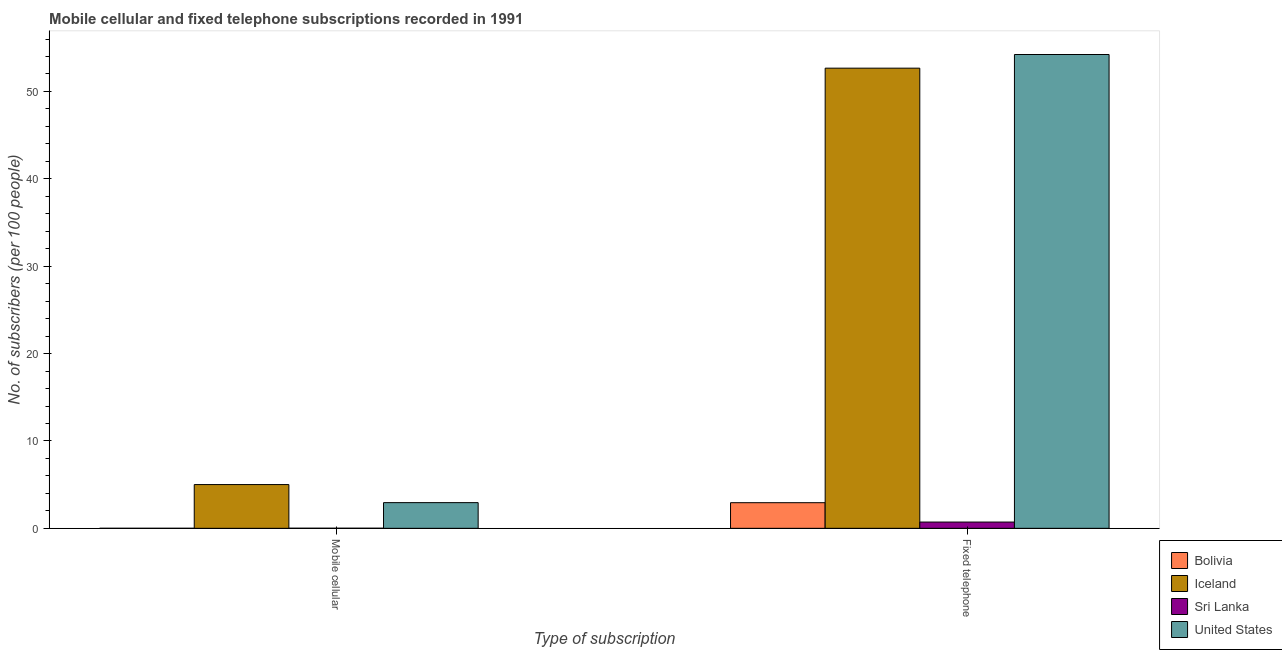How many different coloured bars are there?
Provide a succinct answer. 4. How many groups of bars are there?
Your response must be concise. 2. Are the number of bars per tick equal to the number of legend labels?
Keep it short and to the point. Yes. How many bars are there on the 1st tick from the left?
Ensure brevity in your answer.  4. What is the label of the 1st group of bars from the left?
Give a very brief answer. Mobile cellular. What is the number of fixed telephone subscribers in Sri Lanka?
Your response must be concise. 0.72. Across all countries, what is the maximum number of mobile cellular subscribers?
Offer a terse response. 5.01. Across all countries, what is the minimum number of mobile cellular subscribers?
Provide a succinct answer. 0. In which country was the number of mobile cellular subscribers maximum?
Give a very brief answer. Iceland. In which country was the number of fixed telephone subscribers minimum?
Provide a succinct answer. Sri Lanka. What is the total number of mobile cellular subscribers in the graph?
Make the answer very short. 7.96. What is the difference between the number of fixed telephone subscribers in Bolivia and that in Sri Lanka?
Keep it short and to the point. 2.22. What is the difference between the number of mobile cellular subscribers in Sri Lanka and the number of fixed telephone subscribers in United States?
Keep it short and to the point. -54.22. What is the average number of fixed telephone subscribers per country?
Your response must be concise. 27.64. What is the difference between the number of fixed telephone subscribers and number of mobile cellular subscribers in United States?
Make the answer very short. 51.29. What is the ratio of the number of mobile cellular subscribers in Iceland to that in Sri Lanka?
Provide a short and direct response. 487.77. Is the number of fixed telephone subscribers in Sri Lanka less than that in Bolivia?
Offer a terse response. Yes. What does the 2nd bar from the left in Fixed telephone represents?
Give a very brief answer. Iceland. How many countries are there in the graph?
Offer a very short reply. 4. What is the difference between two consecutive major ticks on the Y-axis?
Keep it short and to the point. 10. Does the graph contain grids?
Offer a terse response. No. How are the legend labels stacked?
Offer a terse response. Vertical. What is the title of the graph?
Provide a short and direct response. Mobile cellular and fixed telephone subscriptions recorded in 1991. Does "Ukraine" appear as one of the legend labels in the graph?
Provide a short and direct response. No. What is the label or title of the X-axis?
Provide a succinct answer. Type of subscription. What is the label or title of the Y-axis?
Your answer should be very brief. No. of subscribers (per 100 people). What is the No. of subscribers (per 100 people) in Bolivia in Mobile cellular?
Provide a succinct answer. 0. What is the No. of subscribers (per 100 people) of Iceland in Mobile cellular?
Keep it short and to the point. 5.01. What is the No. of subscribers (per 100 people) in Sri Lanka in Mobile cellular?
Provide a succinct answer. 0.01. What is the No. of subscribers (per 100 people) in United States in Mobile cellular?
Keep it short and to the point. 2.94. What is the No. of subscribers (per 100 people) in Bolivia in Fixed telephone?
Keep it short and to the point. 2.93. What is the No. of subscribers (per 100 people) of Iceland in Fixed telephone?
Make the answer very short. 52.67. What is the No. of subscribers (per 100 people) of Sri Lanka in Fixed telephone?
Provide a short and direct response. 0.72. What is the No. of subscribers (per 100 people) of United States in Fixed telephone?
Provide a succinct answer. 54.23. Across all Type of subscription, what is the maximum No. of subscribers (per 100 people) in Bolivia?
Make the answer very short. 2.93. Across all Type of subscription, what is the maximum No. of subscribers (per 100 people) of Iceland?
Offer a terse response. 52.67. Across all Type of subscription, what is the maximum No. of subscribers (per 100 people) of Sri Lanka?
Your answer should be very brief. 0.72. Across all Type of subscription, what is the maximum No. of subscribers (per 100 people) in United States?
Offer a terse response. 54.23. Across all Type of subscription, what is the minimum No. of subscribers (per 100 people) of Bolivia?
Provide a succinct answer. 0. Across all Type of subscription, what is the minimum No. of subscribers (per 100 people) of Iceland?
Provide a succinct answer. 5.01. Across all Type of subscription, what is the minimum No. of subscribers (per 100 people) in Sri Lanka?
Your response must be concise. 0.01. Across all Type of subscription, what is the minimum No. of subscribers (per 100 people) of United States?
Make the answer very short. 2.94. What is the total No. of subscribers (per 100 people) in Bolivia in the graph?
Your answer should be compact. 2.94. What is the total No. of subscribers (per 100 people) in Iceland in the graph?
Offer a terse response. 57.67. What is the total No. of subscribers (per 100 people) in Sri Lanka in the graph?
Your response must be concise. 0.73. What is the total No. of subscribers (per 100 people) of United States in the graph?
Keep it short and to the point. 57.17. What is the difference between the No. of subscribers (per 100 people) of Bolivia in Mobile cellular and that in Fixed telephone?
Offer a terse response. -2.93. What is the difference between the No. of subscribers (per 100 people) in Iceland in Mobile cellular and that in Fixed telephone?
Your answer should be very brief. -47.66. What is the difference between the No. of subscribers (per 100 people) of Sri Lanka in Mobile cellular and that in Fixed telephone?
Provide a succinct answer. -0.71. What is the difference between the No. of subscribers (per 100 people) of United States in Mobile cellular and that in Fixed telephone?
Keep it short and to the point. -51.29. What is the difference between the No. of subscribers (per 100 people) in Bolivia in Mobile cellular and the No. of subscribers (per 100 people) in Iceland in Fixed telephone?
Provide a succinct answer. -52.66. What is the difference between the No. of subscribers (per 100 people) in Bolivia in Mobile cellular and the No. of subscribers (per 100 people) in Sri Lanka in Fixed telephone?
Make the answer very short. -0.71. What is the difference between the No. of subscribers (per 100 people) in Bolivia in Mobile cellular and the No. of subscribers (per 100 people) in United States in Fixed telephone?
Your answer should be compact. -54.23. What is the difference between the No. of subscribers (per 100 people) of Iceland in Mobile cellular and the No. of subscribers (per 100 people) of Sri Lanka in Fixed telephone?
Your answer should be very brief. 4.29. What is the difference between the No. of subscribers (per 100 people) of Iceland in Mobile cellular and the No. of subscribers (per 100 people) of United States in Fixed telephone?
Make the answer very short. -49.22. What is the difference between the No. of subscribers (per 100 people) in Sri Lanka in Mobile cellular and the No. of subscribers (per 100 people) in United States in Fixed telephone?
Give a very brief answer. -54.22. What is the average No. of subscribers (per 100 people) in Bolivia per Type of subscription?
Provide a succinct answer. 1.47. What is the average No. of subscribers (per 100 people) in Iceland per Type of subscription?
Offer a very short reply. 28.84. What is the average No. of subscribers (per 100 people) in Sri Lanka per Type of subscription?
Provide a succinct answer. 0.36. What is the average No. of subscribers (per 100 people) of United States per Type of subscription?
Offer a very short reply. 28.58. What is the difference between the No. of subscribers (per 100 people) in Bolivia and No. of subscribers (per 100 people) in Iceland in Mobile cellular?
Provide a short and direct response. -5. What is the difference between the No. of subscribers (per 100 people) in Bolivia and No. of subscribers (per 100 people) in Sri Lanka in Mobile cellular?
Your answer should be very brief. -0.01. What is the difference between the No. of subscribers (per 100 people) in Bolivia and No. of subscribers (per 100 people) in United States in Mobile cellular?
Make the answer very short. -2.94. What is the difference between the No. of subscribers (per 100 people) of Iceland and No. of subscribers (per 100 people) of Sri Lanka in Mobile cellular?
Offer a terse response. 5. What is the difference between the No. of subscribers (per 100 people) of Iceland and No. of subscribers (per 100 people) of United States in Mobile cellular?
Make the answer very short. 2.07. What is the difference between the No. of subscribers (per 100 people) in Sri Lanka and No. of subscribers (per 100 people) in United States in Mobile cellular?
Make the answer very short. -2.93. What is the difference between the No. of subscribers (per 100 people) in Bolivia and No. of subscribers (per 100 people) in Iceland in Fixed telephone?
Ensure brevity in your answer.  -49.73. What is the difference between the No. of subscribers (per 100 people) in Bolivia and No. of subscribers (per 100 people) in Sri Lanka in Fixed telephone?
Make the answer very short. 2.22. What is the difference between the No. of subscribers (per 100 people) of Bolivia and No. of subscribers (per 100 people) of United States in Fixed telephone?
Keep it short and to the point. -51.3. What is the difference between the No. of subscribers (per 100 people) in Iceland and No. of subscribers (per 100 people) in Sri Lanka in Fixed telephone?
Provide a succinct answer. 51.95. What is the difference between the No. of subscribers (per 100 people) in Iceland and No. of subscribers (per 100 people) in United States in Fixed telephone?
Offer a very short reply. -1.56. What is the difference between the No. of subscribers (per 100 people) of Sri Lanka and No. of subscribers (per 100 people) of United States in Fixed telephone?
Ensure brevity in your answer.  -53.51. What is the ratio of the No. of subscribers (per 100 people) in Bolivia in Mobile cellular to that in Fixed telephone?
Keep it short and to the point. 0. What is the ratio of the No. of subscribers (per 100 people) of Iceland in Mobile cellular to that in Fixed telephone?
Ensure brevity in your answer.  0.1. What is the ratio of the No. of subscribers (per 100 people) in Sri Lanka in Mobile cellular to that in Fixed telephone?
Ensure brevity in your answer.  0.01. What is the ratio of the No. of subscribers (per 100 people) in United States in Mobile cellular to that in Fixed telephone?
Provide a short and direct response. 0.05. What is the difference between the highest and the second highest No. of subscribers (per 100 people) in Bolivia?
Ensure brevity in your answer.  2.93. What is the difference between the highest and the second highest No. of subscribers (per 100 people) in Iceland?
Provide a short and direct response. 47.66. What is the difference between the highest and the second highest No. of subscribers (per 100 people) in Sri Lanka?
Offer a very short reply. 0.71. What is the difference between the highest and the second highest No. of subscribers (per 100 people) in United States?
Give a very brief answer. 51.29. What is the difference between the highest and the lowest No. of subscribers (per 100 people) in Bolivia?
Your response must be concise. 2.93. What is the difference between the highest and the lowest No. of subscribers (per 100 people) of Iceland?
Make the answer very short. 47.66. What is the difference between the highest and the lowest No. of subscribers (per 100 people) of Sri Lanka?
Offer a terse response. 0.71. What is the difference between the highest and the lowest No. of subscribers (per 100 people) of United States?
Your response must be concise. 51.29. 